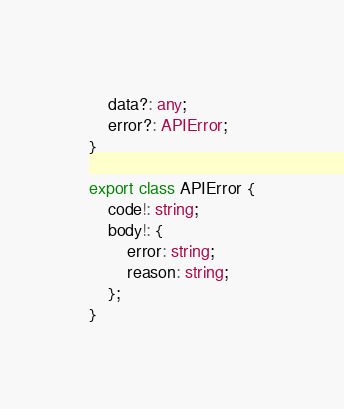Convert code to text. <code><loc_0><loc_0><loc_500><loc_500><_TypeScript_>    data?: any;
    error?: APIError;
}

export class APIError {
    code!: string;
    body!: {
        error: string;
        reason: string;
    };
}
</code> 